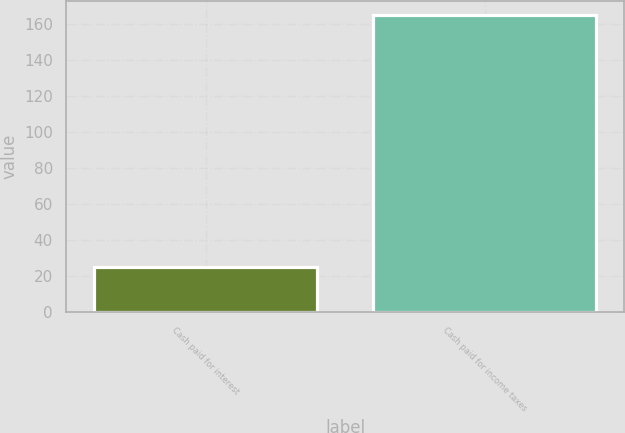<chart> <loc_0><loc_0><loc_500><loc_500><bar_chart><fcel>Cash paid for interest<fcel>Cash paid for income taxes<nl><fcel>25.1<fcel>165<nl></chart> 